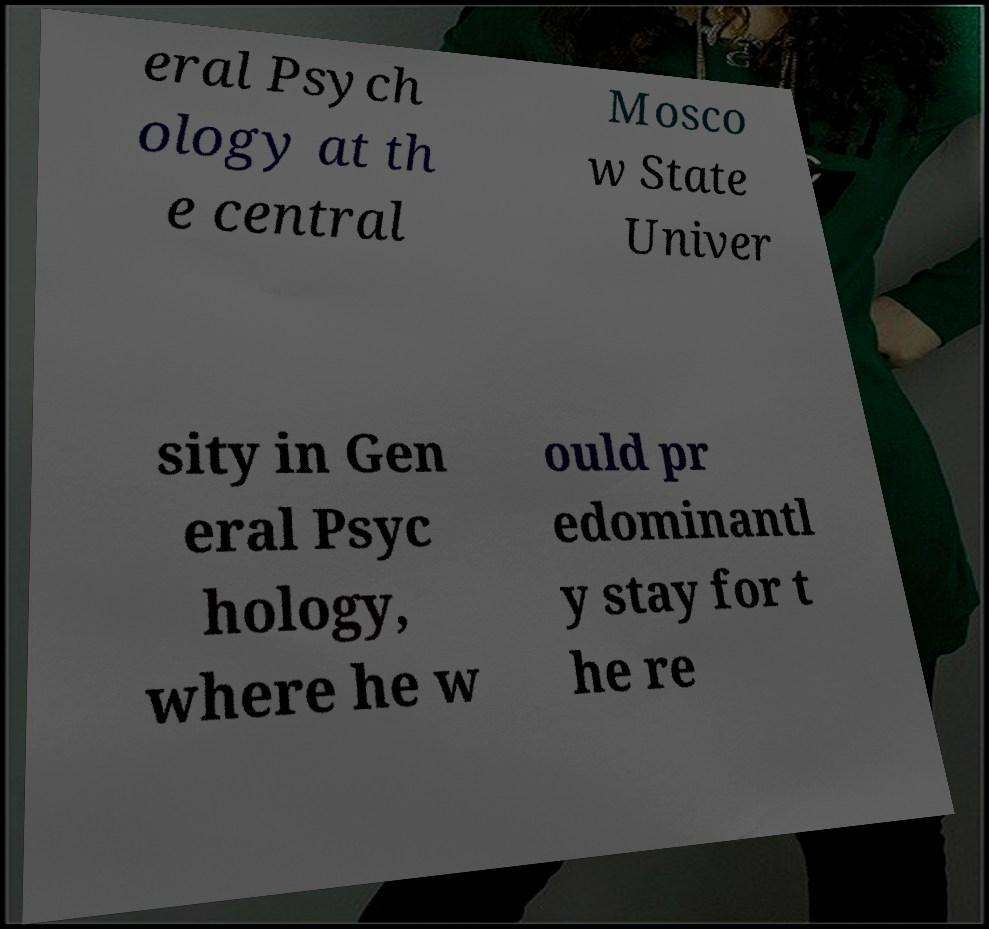Please identify and transcribe the text found in this image. eral Psych ology at th e central Mosco w State Univer sity in Gen eral Psyc hology, where he w ould pr edominantl y stay for t he re 